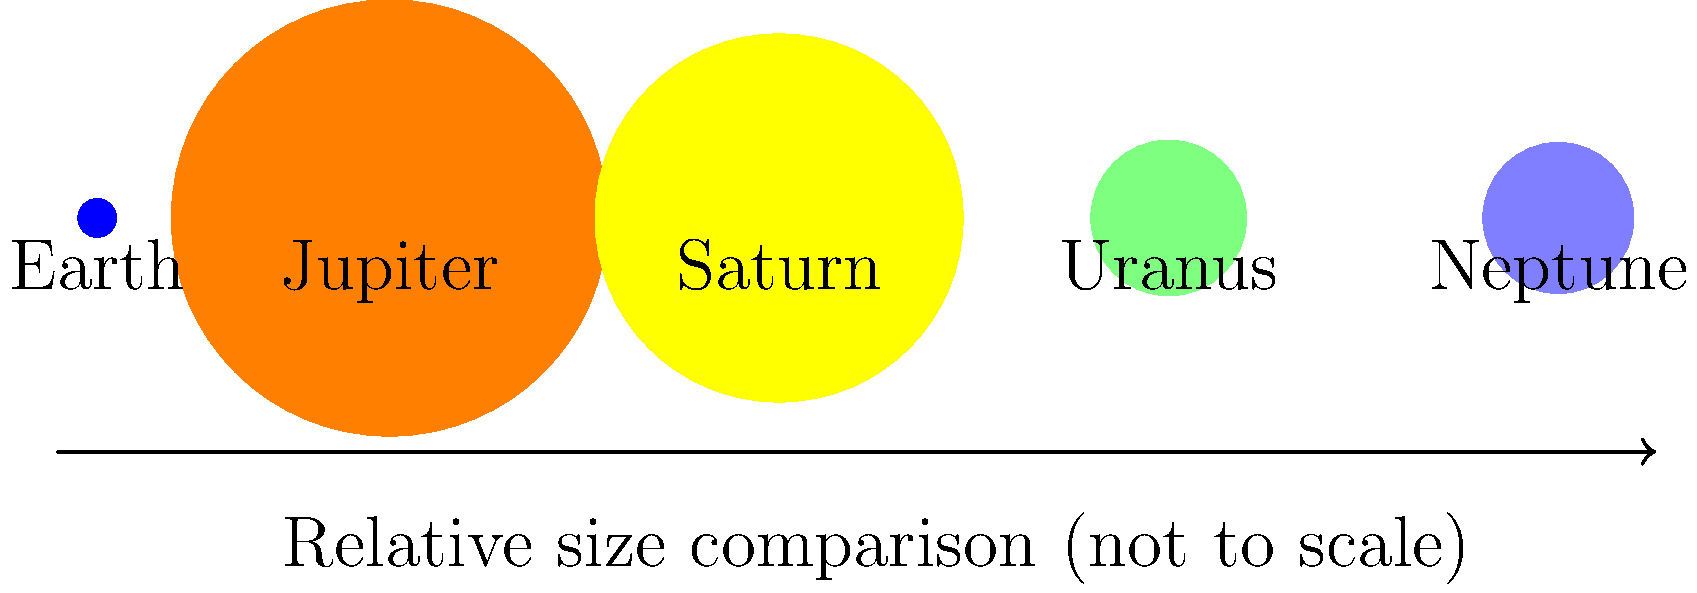As a resident of Saratoga, Minnesota, you're organizing a local astronomy event to educate children about our solar system. Using the scaled circular diagram above, which shows the relative sizes of Earth and the gas giants, how many times larger is Jupiter's diameter compared to Earth's? To determine how many times larger Jupiter's diameter is compared to Earth's, we'll follow these steps:

1. Identify the radii given in the diagram:
   Earth radius = 1 unit
   Jupiter radius = 11.2 units

2. Recall that diameter is twice the radius for a circle.

3. Calculate Earth's diameter:
   Earth diameter = 2 × 1 = 2 units

4. Calculate Jupiter's diameter:
   Jupiter diameter = 2 × 11.2 = 22.4 units

5. Compare Jupiter's diameter to Earth's:
   Ratio = Jupiter diameter ÷ Earth diameter
   Ratio = 22.4 ÷ 2 = 11.2

Therefore, Jupiter's diameter is 11.2 times larger than Earth's diameter.
Answer: 11.2 times 